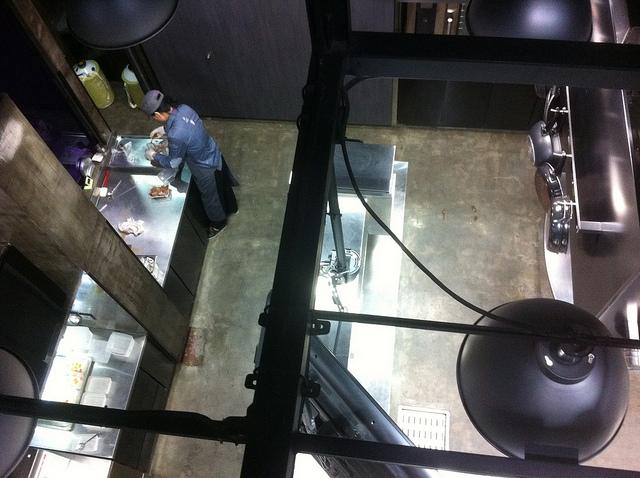What viewpoint is this picture taken?
Concise answer only. Above. What is the man doing?
Answer briefly. Cooking. Is this an interior of a home?
Be succinct. No. 